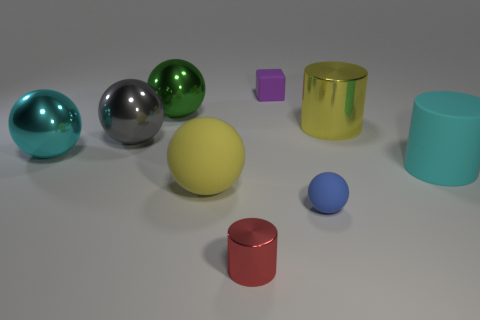Is there any other thing that has the same shape as the small purple matte thing?
Your response must be concise. No. The red metallic object that is the same shape as the big cyan matte object is what size?
Give a very brief answer. Small. What is the shape of the cyan shiny object?
Ensure brevity in your answer.  Sphere. Is the material of the large cyan cylinder the same as the big ball on the right side of the green shiny ball?
Provide a succinct answer. Yes. What number of metallic things are red cylinders or cyan things?
Offer a very short reply. 2. What size is the ball behind the big yellow shiny object?
Your response must be concise. Large. The purple block that is the same material as the tiny blue thing is what size?
Your answer should be compact. Small. What number of big rubber things have the same color as the big shiny cylinder?
Ensure brevity in your answer.  1. Is there a gray ball?
Give a very brief answer. Yes. There is a tiny red object; is it the same shape as the yellow object behind the rubber cylinder?
Give a very brief answer. Yes. 